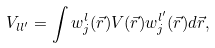<formula> <loc_0><loc_0><loc_500><loc_500>V _ { l l ^ { \prime } } = \int w _ { j } ^ { l } ( \vec { r } ) V ( \vec { r } ) w _ { j } ^ { l ^ { \prime } } ( \vec { r } ) d \vec { r } ,</formula> 